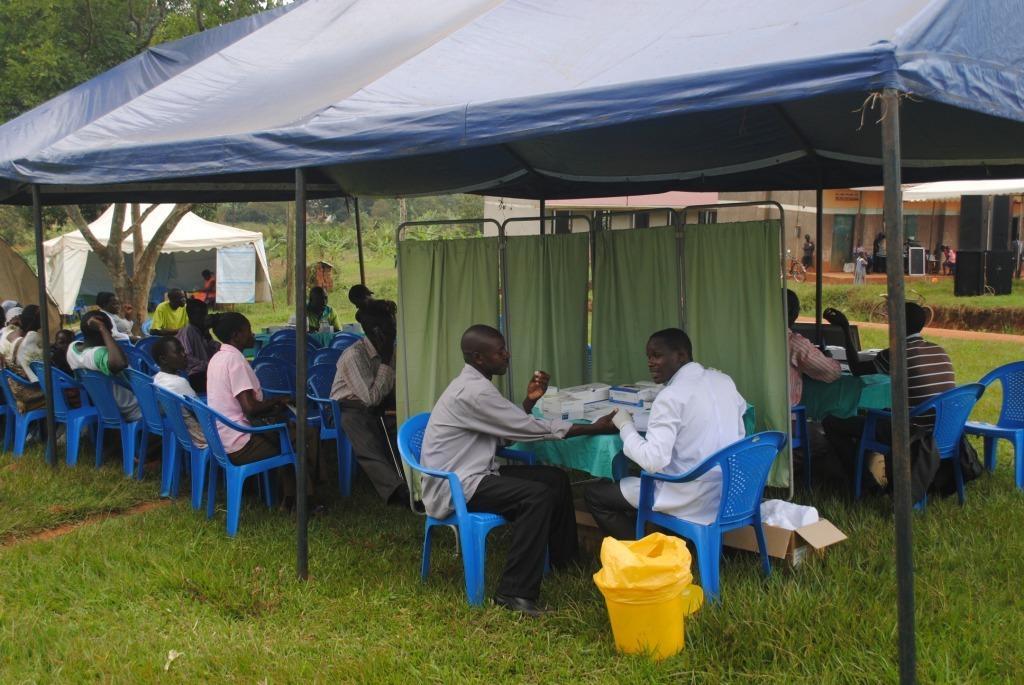Can you describe this image briefly? In this image we have 2 persons sitting in the chair near the table and in the table there are some boxes and some group of people sitting in the chair a the left side and some group of people sitting in the chair at the right side and at the back ground we have tent , trees , building , speakers and some plants. 